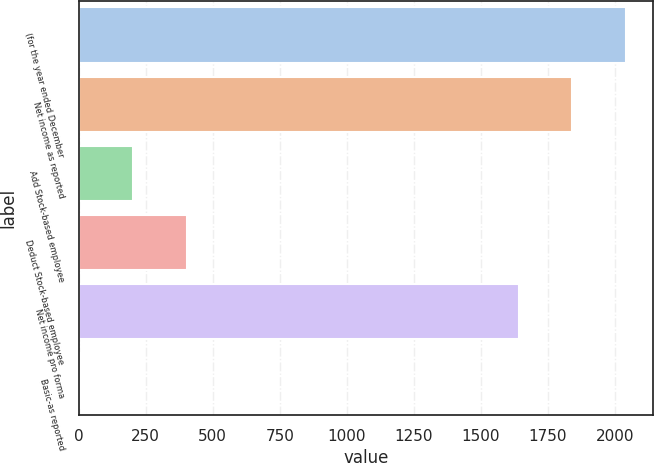Convert chart to OTSL. <chart><loc_0><loc_0><loc_500><loc_500><bar_chart><fcel>(for the year ended December<fcel>Net income as reported<fcel>Add Stock-based employee<fcel>Deduct Stock-based employee<fcel>Net income pro forma<fcel>Basic-as reported<nl><fcel>2040.82<fcel>1840.91<fcel>203.82<fcel>403.73<fcel>1641<fcel>3.91<nl></chart> 